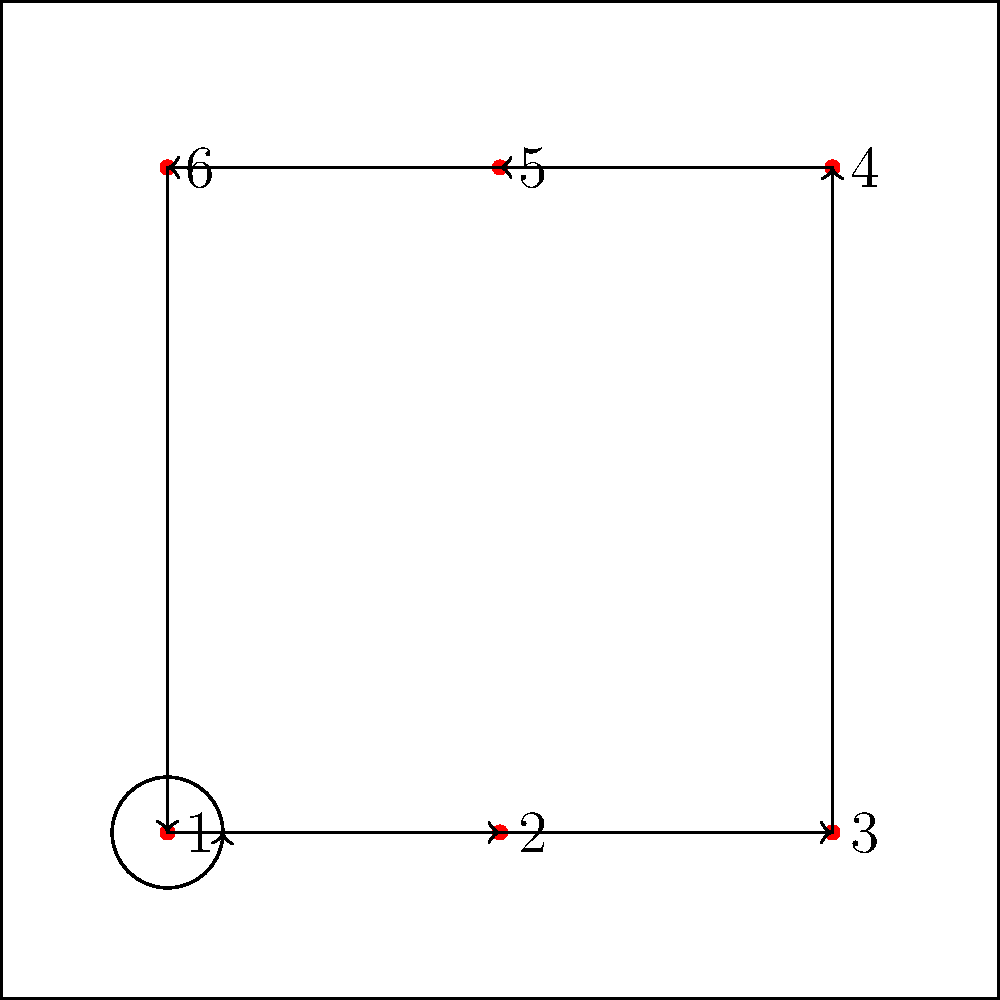In a volleyball match, Lacey is positioned as player 3. After two rotations, what will be her new position number? To solve this problem, we need to understand the rotation pattern in volleyball:

1. The rotation occurs in a clockwise direction.
2. Each rotation moves players to the next position in the sequence: 1 → 2 → 3 → 4 → 5 → 6 → 1.

Let's follow Lacey's position through two rotations:

1. Initially, Lacey is in position 3.
2. After the first rotation:
   - Position 3 moves to position 4
3. After the second rotation:
   - Position 4 moves to position 5

Therefore, after two rotations, Lacey will be in position 5.
Answer: 5 